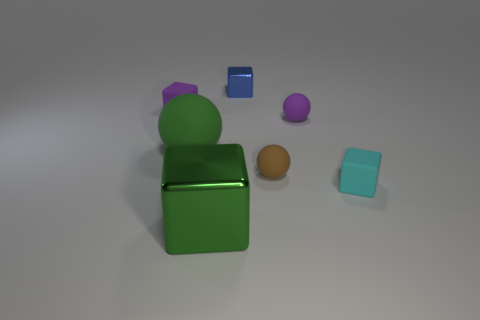There is a blue metal thing; is its shape the same as the object that is to the left of the big green ball?
Offer a very short reply. Yes. What is the size of the rubber thing that is both in front of the purple rubber sphere and on the left side of the big shiny object?
Keep it short and to the point. Large. Are there any cyan objects made of the same material as the tiny brown object?
Provide a succinct answer. Yes. The matte ball that is the same color as the big metallic object is what size?
Ensure brevity in your answer.  Large. There is a tiny purple thing that is in front of the tiny purple object that is on the left side of the big green rubber ball; what is it made of?
Provide a succinct answer. Rubber. What number of small balls have the same color as the large rubber thing?
Ensure brevity in your answer.  0. What size is the thing that is made of the same material as the big block?
Your response must be concise. Small. There is a small purple matte thing on the left side of the big green matte sphere; what shape is it?
Keep it short and to the point. Cube. What is the size of the green thing that is the same shape as the small brown thing?
Make the answer very short. Large. What number of matte cubes are behind the small sphere that is behind the small ball that is in front of the green rubber ball?
Offer a very short reply. 1. 